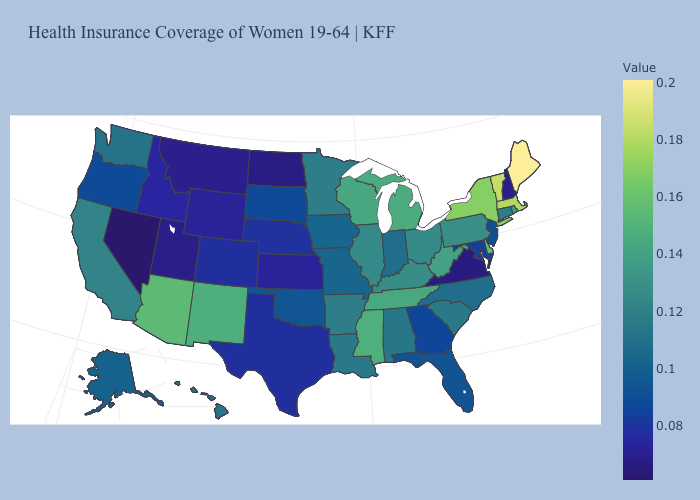Which states have the lowest value in the MidWest?
Give a very brief answer. North Dakota. Does Pennsylvania have a higher value than Colorado?
Short answer required. Yes. Is the legend a continuous bar?
Short answer required. Yes. Does North Dakota have the lowest value in the MidWest?
Keep it brief. Yes. Which states have the lowest value in the West?
Answer briefly. Nevada. Which states have the lowest value in the USA?
Write a very short answer. Nevada. Among the states that border New Mexico , does Utah have the lowest value?
Answer briefly. Yes. Is the legend a continuous bar?
Keep it brief. Yes. Is the legend a continuous bar?
Short answer required. Yes. 